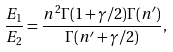Convert formula to latex. <formula><loc_0><loc_0><loc_500><loc_500>\frac { E _ { 1 } } { E _ { 2 } } = \frac { n ^ { 2 } \Gamma ( 1 + \gamma / 2 ) \Gamma ( n ^ { \prime } ) } { \Gamma ( n ^ { \prime } + \gamma / 2 ) } ,</formula> 